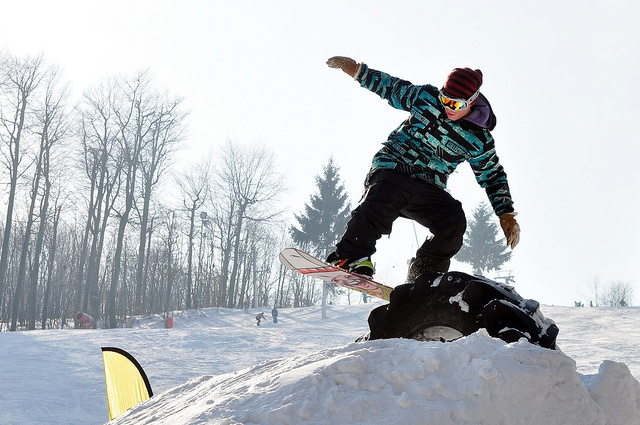Describe the objects in this image and their specific colors. I can see people in white, black, teal, gray, and darkgray tones, snowboard in white, darkgray, lightgray, and gray tones, people in white, gray, and darkgray tones, people in white and gray tones, and people in white, darkgray, and gray tones in this image. 